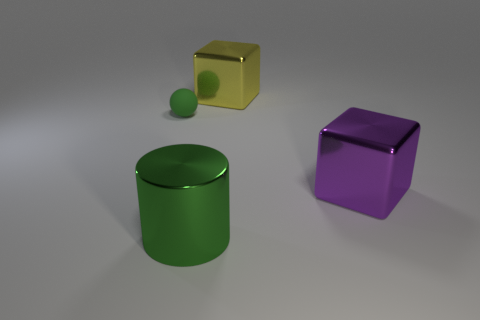Can you tell me what shapes are present in this image? Certainly! The image features a cylindrical green object, a spherical green object, and two cubes - one purple and one yellow with a hole through it. Do the objects have any shadows? Yes, each object casts a soft shadow on the surface beneath it, suggesting there is a light source above and to the right of the scene. 